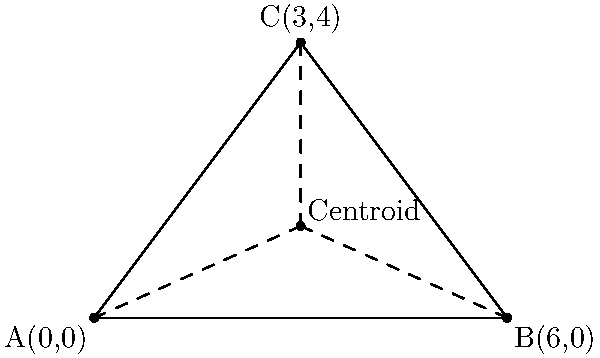In a strategy board game, you're designing a triangular game piece. The vertices of this triangle are located at A(0,0), B(6,0), and C(3,4) on a coordinate plane. To ensure the piece is balanced, you need to find its centroid. What are the coordinates of the centroid? To find the centroid of a triangle, we can use the following steps:

1. The centroid formula for a triangle is:
   $$(\frac{x_1 + x_2 + x_3}{3}, \frac{y_1 + y_2 + y_3}{3})$$
   where $(x_1, y_1)$, $(x_2, y_2)$, and $(x_3, y_3)$ are the coordinates of the three vertices.

2. We have the following coordinates:
   A(0,0), B(6,0), and C(3,4)

3. Let's calculate the x-coordinate of the centroid:
   $$x = \frac{0 + 6 + 3}{3} = \frac{9}{3} = 3$$

4. Now, let's calculate the y-coordinate of the centroid:
   $$y = \frac{0 + 0 + 4}{3} = \frac{4}{3} \approx 1.33$$

5. Therefore, the coordinates of the centroid are (3, 4/3).

This point represents the center of mass of the triangular game piece, ensuring it's balanced when placed on the game board.
Answer: (3, 4/3) 